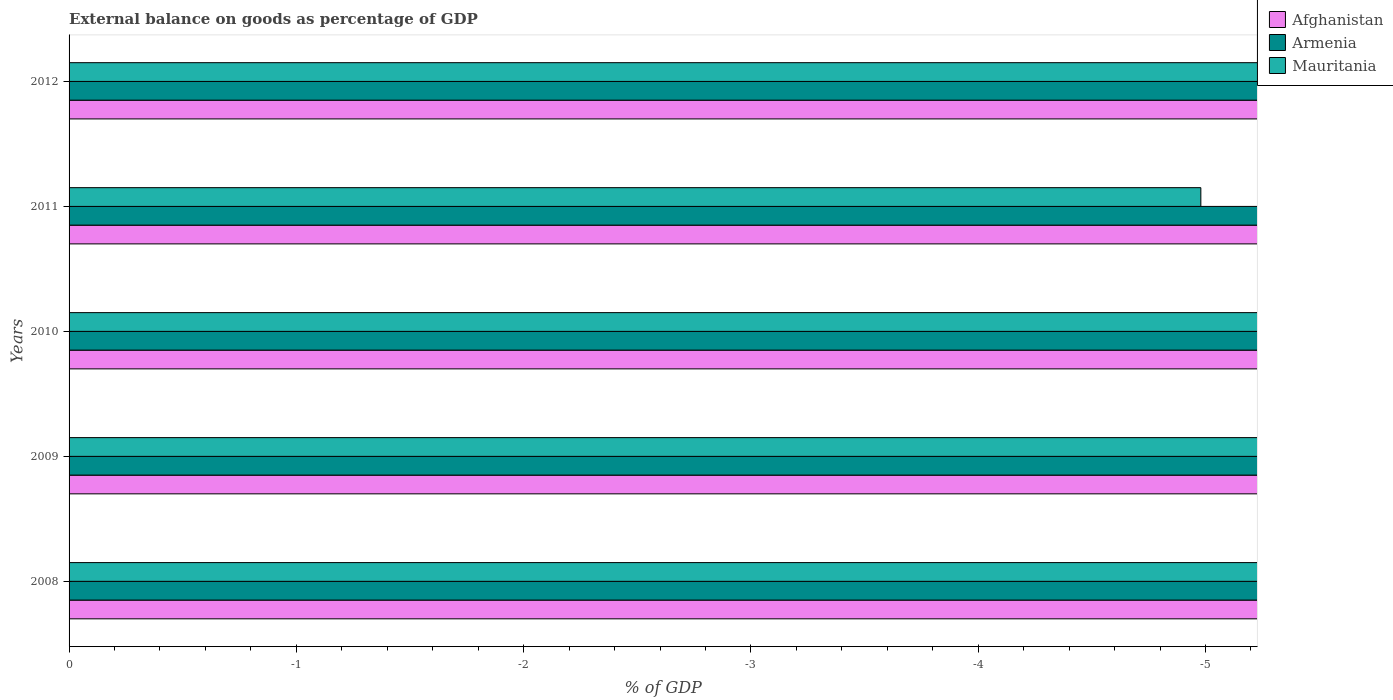Are the number of bars per tick equal to the number of legend labels?
Give a very brief answer. No. How many bars are there on the 3rd tick from the top?
Ensure brevity in your answer.  0. How many bars are there on the 2nd tick from the bottom?
Ensure brevity in your answer.  0. What is the label of the 2nd group of bars from the top?
Make the answer very short. 2011. What is the external balance on goods as percentage of GDP in Armenia in 2012?
Provide a succinct answer. 0. In how many years, is the external balance on goods as percentage of GDP in Mauritania greater than -3.8 %?
Provide a short and direct response. 0. In how many years, is the external balance on goods as percentage of GDP in Mauritania greater than the average external balance on goods as percentage of GDP in Mauritania taken over all years?
Offer a very short reply. 0. Are all the bars in the graph horizontal?
Offer a terse response. Yes. How many years are there in the graph?
Keep it short and to the point. 5. Does the graph contain any zero values?
Provide a short and direct response. Yes. Does the graph contain grids?
Your answer should be compact. No. Where does the legend appear in the graph?
Your answer should be very brief. Top right. How many legend labels are there?
Provide a succinct answer. 3. How are the legend labels stacked?
Your answer should be compact. Vertical. What is the title of the graph?
Offer a very short reply. External balance on goods as percentage of GDP. What is the label or title of the X-axis?
Offer a terse response. % of GDP. What is the label or title of the Y-axis?
Your answer should be very brief. Years. What is the % of GDP of Afghanistan in 2008?
Provide a succinct answer. 0. What is the % of GDP of Armenia in 2008?
Your answer should be compact. 0. What is the % of GDP of Mauritania in 2008?
Your answer should be compact. 0. What is the % of GDP in Mauritania in 2009?
Keep it short and to the point. 0. What is the % of GDP in Armenia in 2010?
Provide a succinct answer. 0. What is the % of GDP in Armenia in 2011?
Ensure brevity in your answer.  0. What is the % of GDP of Mauritania in 2011?
Your answer should be very brief. 0. What is the % of GDP of Armenia in 2012?
Provide a succinct answer. 0. What is the total % of GDP of Mauritania in the graph?
Provide a succinct answer. 0. 